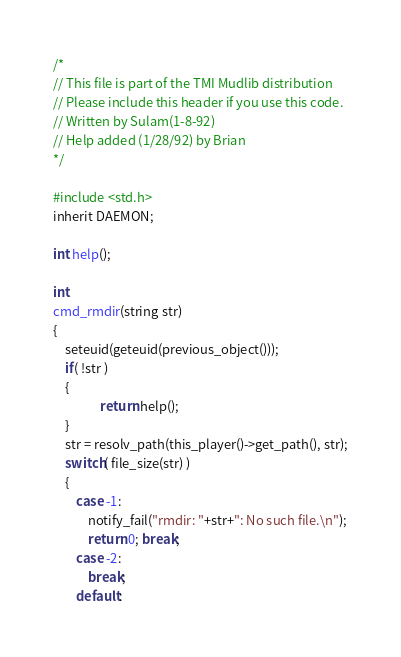Convert code to text. <code><loc_0><loc_0><loc_500><loc_500><_C_>/*
// This file is part of the TMI Mudlib distribution
// Please include this header if you use this code.
// Written by Sulam(1-8-92)
// Help added (1/28/92) by Brian
*/

#include <std.h>
inherit DAEMON;

int help();

int 
cmd_rmdir(string str)
{
	seteuid(geteuid(previous_object()));
	if( !str )
	{
                return help();
	}
	str = resolv_path(this_player()->get_path(), str);
	switch( file_size(str) )
	{
		case -1:
			notify_fail("rmdir: "+str+": No such file.\n");
			return 0; break;
		case -2:
			break;
		default:</code> 